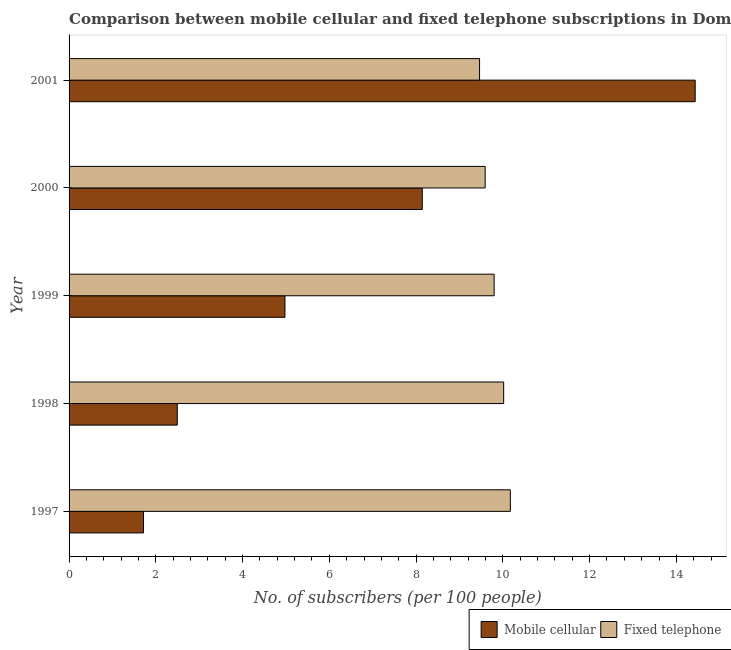How many different coloured bars are there?
Your answer should be very brief. 2. How many groups of bars are there?
Give a very brief answer. 5. Are the number of bars per tick equal to the number of legend labels?
Your answer should be compact. Yes. Are the number of bars on each tick of the Y-axis equal?
Your answer should be very brief. Yes. How many bars are there on the 3rd tick from the bottom?
Ensure brevity in your answer.  2. What is the number of fixed telephone subscribers in 2001?
Your answer should be compact. 9.46. Across all years, what is the maximum number of fixed telephone subscribers?
Give a very brief answer. 10.17. Across all years, what is the minimum number of fixed telephone subscribers?
Offer a terse response. 9.46. In which year was the number of fixed telephone subscribers maximum?
Offer a terse response. 1997. What is the total number of fixed telephone subscribers in the graph?
Make the answer very short. 49.05. What is the difference between the number of mobile cellular subscribers in 1999 and that in 2001?
Give a very brief answer. -9.46. What is the difference between the number of fixed telephone subscribers in 2001 and the number of mobile cellular subscribers in 2000?
Provide a succinct answer. 1.32. What is the average number of fixed telephone subscribers per year?
Provide a succinct answer. 9.81. In the year 2001, what is the difference between the number of mobile cellular subscribers and number of fixed telephone subscribers?
Your response must be concise. 4.97. What is the ratio of the number of mobile cellular subscribers in 1997 to that in 1998?
Keep it short and to the point. 0.69. Is the number of mobile cellular subscribers in 1997 less than that in 1998?
Ensure brevity in your answer.  Yes. What is the difference between the highest and the second highest number of fixed telephone subscribers?
Offer a terse response. 0.15. What is the difference between the highest and the lowest number of fixed telephone subscribers?
Give a very brief answer. 0.71. In how many years, is the number of fixed telephone subscribers greater than the average number of fixed telephone subscribers taken over all years?
Ensure brevity in your answer.  2. What does the 2nd bar from the top in 2001 represents?
Offer a very short reply. Mobile cellular. What does the 1st bar from the bottom in 1997 represents?
Provide a short and direct response. Mobile cellular. How many bars are there?
Offer a terse response. 10. Are all the bars in the graph horizontal?
Make the answer very short. Yes. How many years are there in the graph?
Make the answer very short. 5. Does the graph contain any zero values?
Your response must be concise. No. Does the graph contain grids?
Give a very brief answer. No. Where does the legend appear in the graph?
Ensure brevity in your answer.  Bottom right. How many legend labels are there?
Keep it short and to the point. 2. What is the title of the graph?
Provide a short and direct response. Comparison between mobile cellular and fixed telephone subscriptions in Dominican Republic. Does "% of gross capital formation" appear as one of the legend labels in the graph?
Your answer should be very brief. No. What is the label or title of the X-axis?
Offer a very short reply. No. of subscribers (per 100 people). What is the No. of subscribers (per 100 people) of Mobile cellular in 1997?
Your answer should be compact. 1.71. What is the No. of subscribers (per 100 people) of Fixed telephone in 1997?
Provide a short and direct response. 10.17. What is the No. of subscribers (per 100 people) in Mobile cellular in 1998?
Provide a short and direct response. 2.49. What is the No. of subscribers (per 100 people) of Fixed telephone in 1998?
Give a very brief answer. 10.02. What is the No. of subscribers (per 100 people) of Mobile cellular in 1999?
Offer a very short reply. 4.98. What is the No. of subscribers (per 100 people) in Fixed telephone in 1999?
Ensure brevity in your answer.  9.8. What is the No. of subscribers (per 100 people) in Mobile cellular in 2000?
Offer a terse response. 8.14. What is the No. of subscribers (per 100 people) in Fixed telephone in 2000?
Provide a short and direct response. 9.59. What is the No. of subscribers (per 100 people) in Mobile cellular in 2001?
Your answer should be compact. 14.43. What is the No. of subscribers (per 100 people) of Fixed telephone in 2001?
Give a very brief answer. 9.46. Across all years, what is the maximum No. of subscribers (per 100 people) in Mobile cellular?
Your answer should be compact. 14.43. Across all years, what is the maximum No. of subscribers (per 100 people) of Fixed telephone?
Your answer should be compact. 10.17. Across all years, what is the minimum No. of subscribers (per 100 people) in Mobile cellular?
Provide a short and direct response. 1.71. Across all years, what is the minimum No. of subscribers (per 100 people) in Fixed telephone?
Offer a terse response. 9.46. What is the total No. of subscribers (per 100 people) of Mobile cellular in the graph?
Keep it short and to the point. 31.76. What is the total No. of subscribers (per 100 people) in Fixed telephone in the graph?
Provide a succinct answer. 49.05. What is the difference between the No. of subscribers (per 100 people) of Mobile cellular in 1997 and that in 1998?
Provide a short and direct response. -0.78. What is the difference between the No. of subscribers (per 100 people) in Fixed telephone in 1997 and that in 1998?
Keep it short and to the point. 0.15. What is the difference between the No. of subscribers (per 100 people) in Mobile cellular in 1997 and that in 1999?
Keep it short and to the point. -3.26. What is the difference between the No. of subscribers (per 100 people) in Fixed telephone in 1997 and that in 1999?
Offer a terse response. 0.37. What is the difference between the No. of subscribers (per 100 people) in Mobile cellular in 1997 and that in 2000?
Offer a very short reply. -6.43. What is the difference between the No. of subscribers (per 100 people) in Fixed telephone in 1997 and that in 2000?
Make the answer very short. 0.58. What is the difference between the No. of subscribers (per 100 people) in Mobile cellular in 1997 and that in 2001?
Give a very brief answer. -12.72. What is the difference between the No. of subscribers (per 100 people) of Fixed telephone in 1997 and that in 2001?
Give a very brief answer. 0.71. What is the difference between the No. of subscribers (per 100 people) in Mobile cellular in 1998 and that in 1999?
Keep it short and to the point. -2.48. What is the difference between the No. of subscribers (per 100 people) in Fixed telephone in 1998 and that in 1999?
Offer a terse response. 0.22. What is the difference between the No. of subscribers (per 100 people) in Mobile cellular in 1998 and that in 2000?
Your answer should be compact. -5.65. What is the difference between the No. of subscribers (per 100 people) in Fixed telephone in 1998 and that in 2000?
Your response must be concise. 0.43. What is the difference between the No. of subscribers (per 100 people) in Mobile cellular in 1998 and that in 2001?
Make the answer very short. -11.94. What is the difference between the No. of subscribers (per 100 people) in Fixed telephone in 1998 and that in 2001?
Your response must be concise. 0.56. What is the difference between the No. of subscribers (per 100 people) in Mobile cellular in 1999 and that in 2000?
Offer a very short reply. -3.17. What is the difference between the No. of subscribers (per 100 people) of Fixed telephone in 1999 and that in 2000?
Your response must be concise. 0.21. What is the difference between the No. of subscribers (per 100 people) of Mobile cellular in 1999 and that in 2001?
Provide a short and direct response. -9.46. What is the difference between the No. of subscribers (per 100 people) of Fixed telephone in 1999 and that in 2001?
Keep it short and to the point. 0.34. What is the difference between the No. of subscribers (per 100 people) of Mobile cellular in 2000 and that in 2001?
Your answer should be compact. -6.29. What is the difference between the No. of subscribers (per 100 people) in Fixed telephone in 2000 and that in 2001?
Make the answer very short. 0.13. What is the difference between the No. of subscribers (per 100 people) of Mobile cellular in 1997 and the No. of subscribers (per 100 people) of Fixed telephone in 1998?
Offer a terse response. -8.3. What is the difference between the No. of subscribers (per 100 people) of Mobile cellular in 1997 and the No. of subscribers (per 100 people) of Fixed telephone in 1999?
Provide a succinct answer. -8.08. What is the difference between the No. of subscribers (per 100 people) of Mobile cellular in 1997 and the No. of subscribers (per 100 people) of Fixed telephone in 2000?
Your response must be concise. -7.88. What is the difference between the No. of subscribers (per 100 people) of Mobile cellular in 1997 and the No. of subscribers (per 100 people) of Fixed telephone in 2001?
Provide a succinct answer. -7.75. What is the difference between the No. of subscribers (per 100 people) of Mobile cellular in 1998 and the No. of subscribers (per 100 people) of Fixed telephone in 1999?
Provide a succinct answer. -7.3. What is the difference between the No. of subscribers (per 100 people) of Mobile cellular in 1998 and the No. of subscribers (per 100 people) of Fixed telephone in 2000?
Provide a short and direct response. -7.1. What is the difference between the No. of subscribers (per 100 people) of Mobile cellular in 1998 and the No. of subscribers (per 100 people) of Fixed telephone in 2001?
Provide a succinct answer. -6.97. What is the difference between the No. of subscribers (per 100 people) in Mobile cellular in 1999 and the No. of subscribers (per 100 people) in Fixed telephone in 2000?
Offer a terse response. -4.62. What is the difference between the No. of subscribers (per 100 people) of Mobile cellular in 1999 and the No. of subscribers (per 100 people) of Fixed telephone in 2001?
Provide a succinct answer. -4.49. What is the difference between the No. of subscribers (per 100 people) in Mobile cellular in 2000 and the No. of subscribers (per 100 people) in Fixed telephone in 2001?
Provide a short and direct response. -1.32. What is the average No. of subscribers (per 100 people) of Mobile cellular per year?
Offer a terse response. 6.35. What is the average No. of subscribers (per 100 people) in Fixed telephone per year?
Offer a very short reply. 9.81. In the year 1997, what is the difference between the No. of subscribers (per 100 people) of Mobile cellular and No. of subscribers (per 100 people) of Fixed telephone?
Keep it short and to the point. -8.46. In the year 1998, what is the difference between the No. of subscribers (per 100 people) in Mobile cellular and No. of subscribers (per 100 people) in Fixed telephone?
Provide a short and direct response. -7.52. In the year 1999, what is the difference between the No. of subscribers (per 100 people) of Mobile cellular and No. of subscribers (per 100 people) of Fixed telephone?
Your response must be concise. -4.82. In the year 2000, what is the difference between the No. of subscribers (per 100 people) in Mobile cellular and No. of subscribers (per 100 people) in Fixed telephone?
Offer a terse response. -1.45. In the year 2001, what is the difference between the No. of subscribers (per 100 people) of Mobile cellular and No. of subscribers (per 100 people) of Fixed telephone?
Provide a short and direct response. 4.97. What is the ratio of the No. of subscribers (per 100 people) in Mobile cellular in 1997 to that in 1998?
Provide a short and direct response. 0.69. What is the ratio of the No. of subscribers (per 100 people) in Fixed telephone in 1997 to that in 1998?
Provide a short and direct response. 1.02. What is the ratio of the No. of subscribers (per 100 people) in Mobile cellular in 1997 to that in 1999?
Make the answer very short. 0.34. What is the ratio of the No. of subscribers (per 100 people) of Fixed telephone in 1997 to that in 1999?
Your answer should be compact. 1.04. What is the ratio of the No. of subscribers (per 100 people) in Mobile cellular in 1997 to that in 2000?
Keep it short and to the point. 0.21. What is the ratio of the No. of subscribers (per 100 people) of Fixed telephone in 1997 to that in 2000?
Provide a short and direct response. 1.06. What is the ratio of the No. of subscribers (per 100 people) in Mobile cellular in 1997 to that in 2001?
Provide a short and direct response. 0.12. What is the ratio of the No. of subscribers (per 100 people) in Fixed telephone in 1997 to that in 2001?
Offer a very short reply. 1.07. What is the ratio of the No. of subscribers (per 100 people) in Mobile cellular in 1998 to that in 1999?
Give a very brief answer. 0.5. What is the ratio of the No. of subscribers (per 100 people) of Fixed telephone in 1998 to that in 1999?
Provide a succinct answer. 1.02. What is the ratio of the No. of subscribers (per 100 people) of Mobile cellular in 1998 to that in 2000?
Provide a succinct answer. 0.31. What is the ratio of the No. of subscribers (per 100 people) of Fixed telephone in 1998 to that in 2000?
Keep it short and to the point. 1.04. What is the ratio of the No. of subscribers (per 100 people) of Mobile cellular in 1998 to that in 2001?
Your response must be concise. 0.17. What is the ratio of the No. of subscribers (per 100 people) of Fixed telephone in 1998 to that in 2001?
Ensure brevity in your answer.  1.06. What is the ratio of the No. of subscribers (per 100 people) in Mobile cellular in 1999 to that in 2000?
Provide a succinct answer. 0.61. What is the ratio of the No. of subscribers (per 100 people) in Fixed telephone in 1999 to that in 2000?
Your answer should be compact. 1.02. What is the ratio of the No. of subscribers (per 100 people) of Mobile cellular in 1999 to that in 2001?
Offer a very short reply. 0.34. What is the ratio of the No. of subscribers (per 100 people) in Fixed telephone in 1999 to that in 2001?
Your response must be concise. 1.04. What is the ratio of the No. of subscribers (per 100 people) in Mobile cellular in 2000 to that in 2001?
Keep it short and to the point. 0.56. What is the ratio of the No. of subscribers (per 100 people) in Fixed telephone in 2000 to that in 2001?
Offer a very short reply. 1.01. What is the difference between the highest and the second highest No. of subscribers (per 100 people) in Mobile cellular?
Make the answer very short. 6.29. What is the difference between the highest and the second highest No. of subscribers (per 100 people) in Fixed telephone?
Provide a short and direct response. 0.15. What is the difference between the highest and the lowest No. of subscribers (per 100 people) in Mobile cellular?
Ensure brevity in your answer.  12.72. What is the difference between the highest and the lowest No. of subscribers (per 100 people) in Fixed telephone?
Your response must be concise. 0.71. 